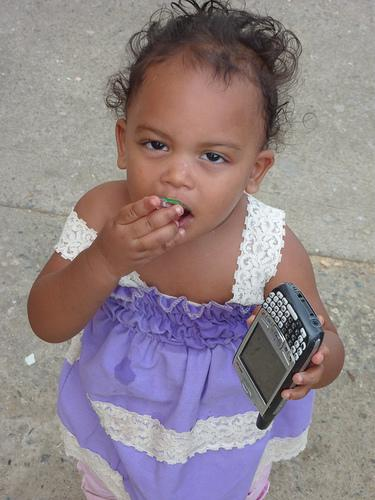Question: where is she?
Choices:
A. At school.
B. On the sidewalk.
C. At work.
D. At a park.
Answer with the letter. Answer: B Question: how many kids?
Choices:
A. 2.
B. 1.
C. 3.
D. 4.
Answer with the letter. Answer: B Question: who is she talking to?
Choices:
A. Her friend.
B. Her boyfriend.
C. People.
D. Her mom.
Answer with the letter. Answer: C Question: what is she holding?
Choices:
A. Phone.
B. Computer.
C. Calculator.
D. Fax machine.
Answer with the letter. Answer: A Question: what color is her dress?
Choices:
A. Green.
B. White.
C. Purple.
D. Black.
Answer with the letter. Answer: C 